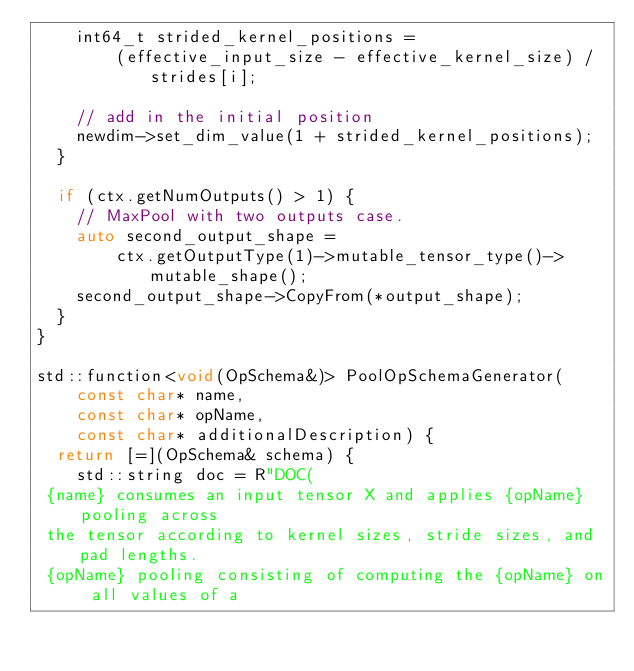Convert code to text. <code><loc_0><loc_0><loc_500><loc_500><_C++_>    int64_t strided_kernel_positions =
        (effective_input_size - effective_kernel_size) / strides[i];

    // add in the initial position
    newdim->set_dim_value(1 + strided_kernel_positions);
  }

  if (ctx.getNumOutputs() > 1) {
    // MaxPool with two outputs case.
    auto second_output_shape =
        ctx.getOutputType(1)->mutable_tensor_type()->mutable_shape();
    second_output_shape->CopyFrom(*output_shape);
  }
}

std::function<void(OpSchema&)> PoolOpSchemaGenerator(
    const char* name,
    const char* opName,
    const char* additionalDescription) {
  return [=](OpSchema& schema) {
    std::string doc = R"DOC(
 {name} consumes an input tensor X and applies {opName} pooling across
 the tensor according to kernel sizes, stride sizes, and pad lengths.
 {opName} pooling consisting of computing the {opName} on all values of a</code> 